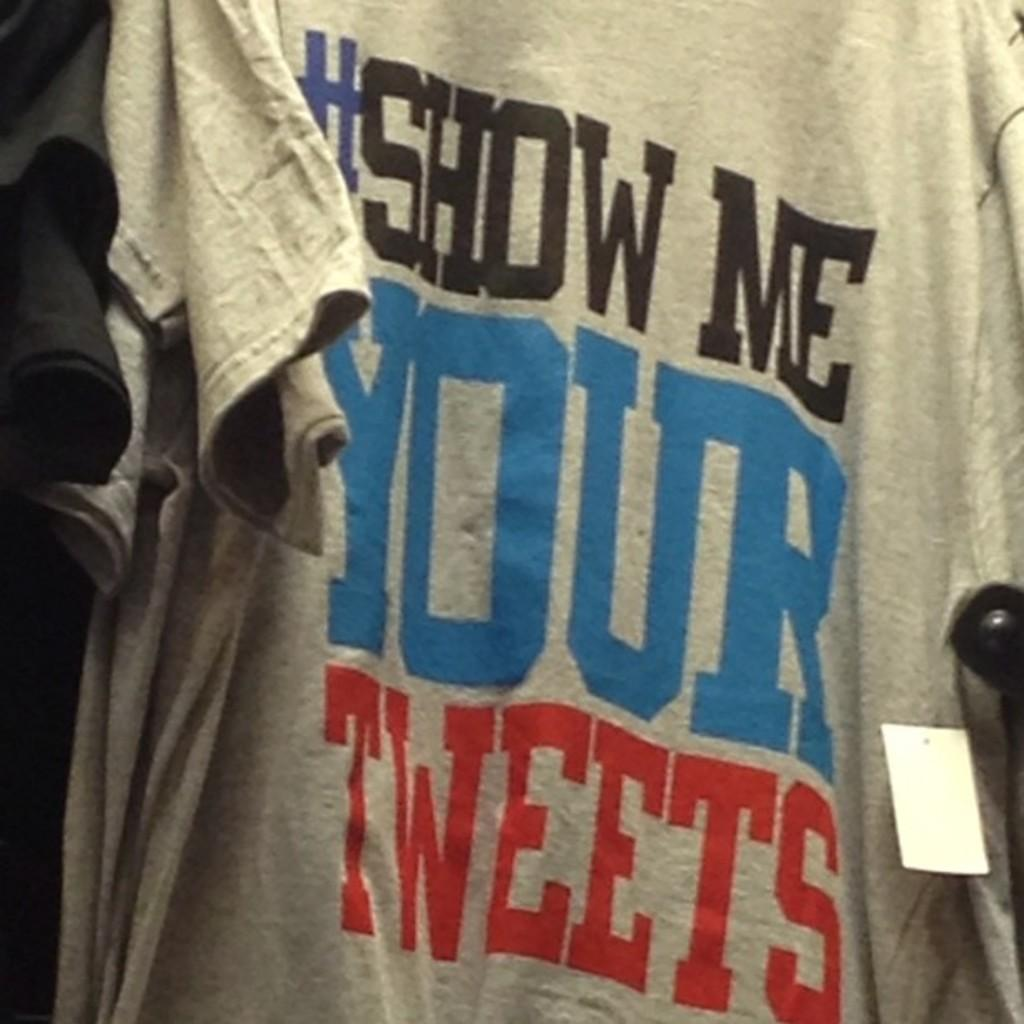<image>
Offer a succinct explanation of the picture presented. A gray #Show me your tweets t-shirt hanging in a store 